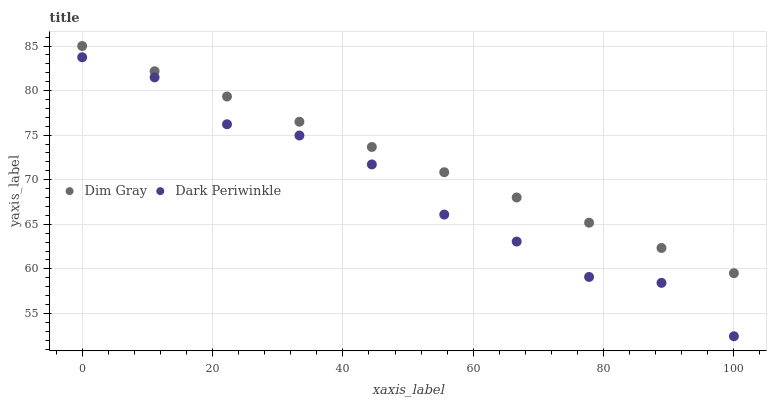Does Dark Periwinkle have the minimum area under the curve?
Answer yes or no. Yes. Does Dim Gray have the maximum area under the curve?
Answer yes or no. Yes. Does Dark Periwinkle have the maximum area under the curve?
Answer yes or no. No. Is Dim Gray the smoothest?
Answer yes or no. Yes. Is Dark Periwinkle the roughest?
Answer yes or no. Yes. Is Dark Periwinkle the smoothest?
Answer yes or no. No. Does Dark Periwinkle have the lowest value?
Answer yes or no. Yes. Does Dim Gray have the highest value?
Answer yes or no. Yes. Does Dark Periwinkle have the highest value?
Answer yes or no. No. Is Dark Periwinkle less than Dim Gray?
Answer yes or no. Yes. Is Dim Gray greater than Dark Periwinkle?
Answer yes or no. Yes. Does Dark Periwinkle intersect Dim Gray?
Answer yes or no. No. 